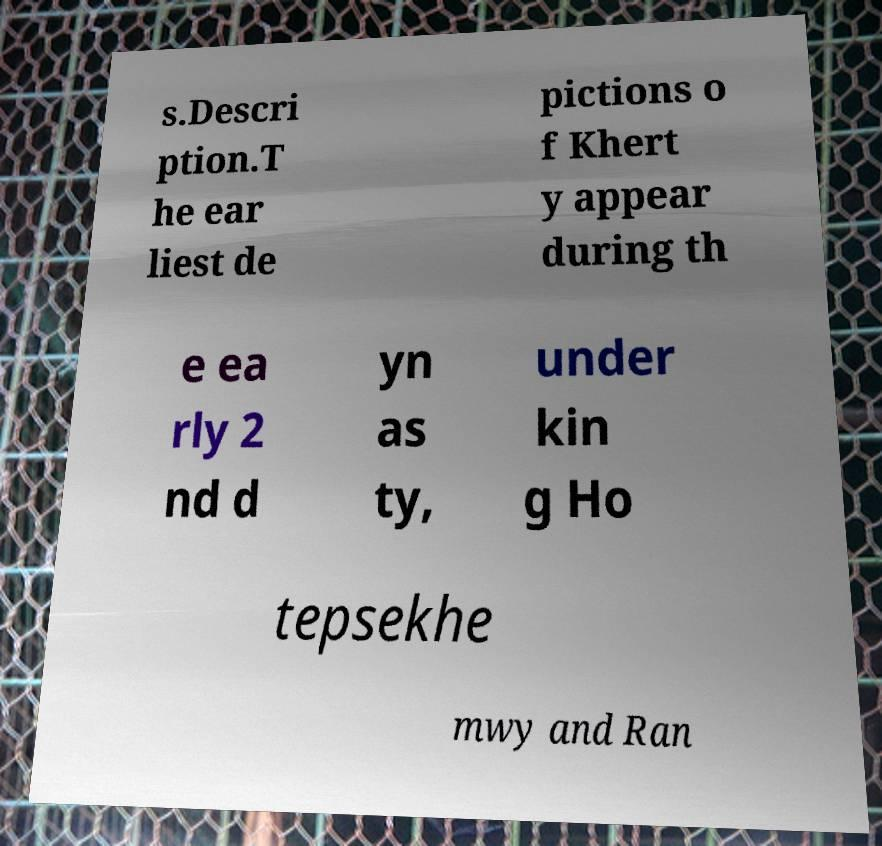What messages or text are displayed in this image? I need them in a readable, typed format. s.Descri ption.T he ear liest de pictions o f Khert y appear during th e ea rly 2 nd d yn as ty, under kin g Ho tepsekhe mwy and Ran 